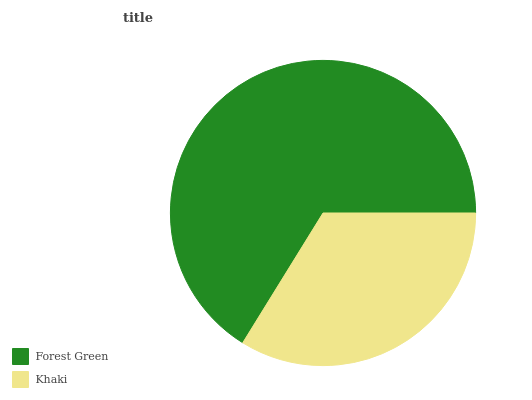Is Khaki the minimum?
Answer yes or no. Yes. Is Forest Green the maximum?
Answer yes or no. Yes. Is Khaki the maximum?
Answer yes or no. No. Is Forest Green greater than Khaki?
Answer yes or no. Yes. Is Khaki less than Forest Green?
Answer yes or no. Yes. Is Khaki greater than Forest Green?
Answer yes or no. No. Is Forest Green less than Khaki?
Answer yes or no. No. Is Forest Green the high median?
Answer yes or no. Yes. Is Khaki the low median?
Answer yes or no. Yes. Is Khaki the high median?
Answer yes or no. No. Is Forest Green the low median?
Answer yes or no. No. 